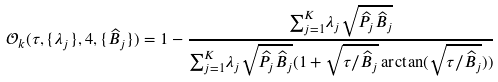<formula> <loc_0><loc_0><loc_500><loc_500>\mathcal { O } _ { k } ( \tau , \{ \lambda _ { j } \} , 4 , \{ \widehat { B } _ { j } \} ) = 1 - \frac { { \sum } _ { j = 1 } ^ { K } \lambda _ { j } \sqrt { \widehat { P } _ { j } \widehat { B } _ { j } } } { { \sum } _ { j = 1 } ^ { K } \lambda _ { j } \sqrt { \widehat { P } _ { j } \widehat { B } _ { j } } ( 1 + \sqrt { \tau / \widehat { B } _ { j } } \arctan ( \sqrt { \tau / \widehat { B } _ { j } } ) ) }</formula> 